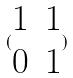<formula> <loc_0><loc_0><loc_500><loc_500>( \begin{matrix} 1 & 1 \\ 0 & 1 \end{matrix} )</formula> 